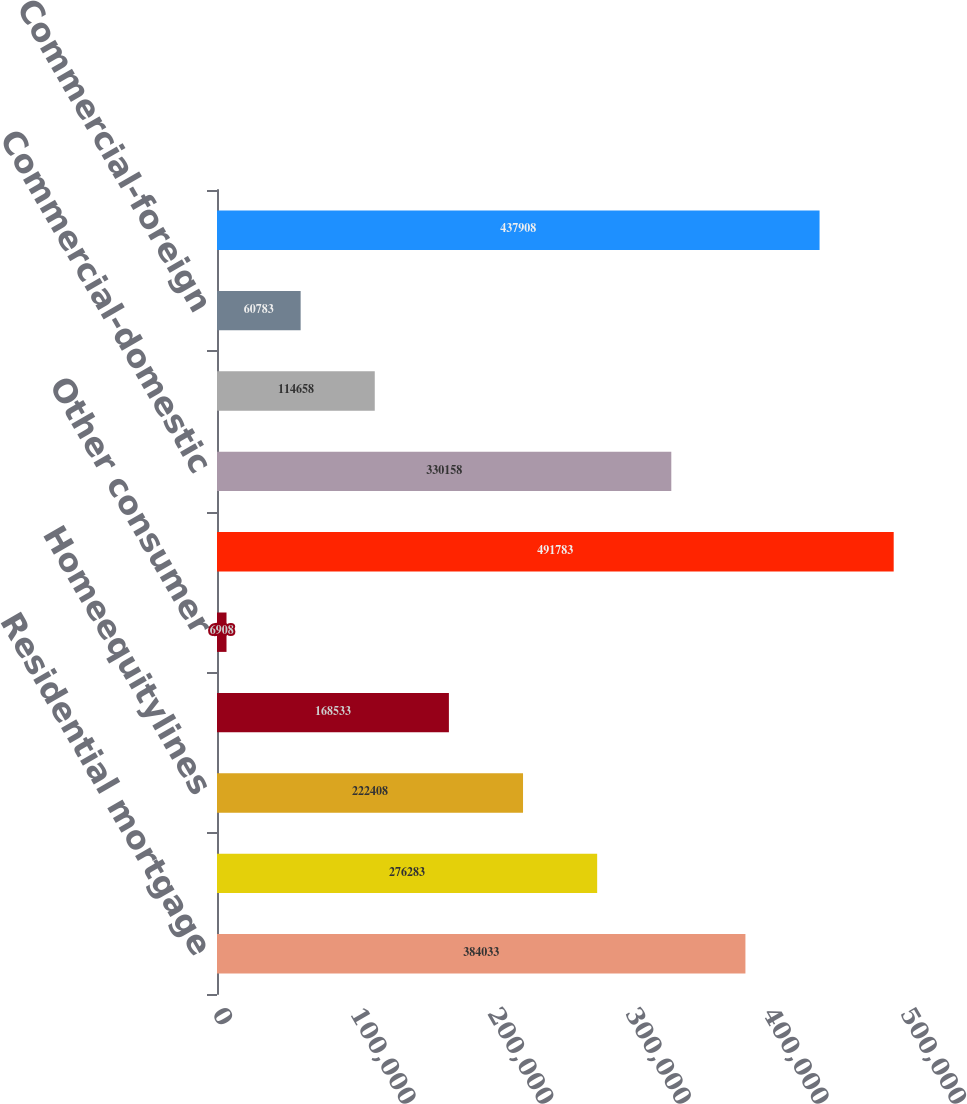Convert chart to OTSL. <chart><loc_0><loc_0><loc_500><loc_500><bar_chart><fcel>Residential mortgage<fcel>Creditcard<fcel>Homeequitylines<fcel>Direct/Indirect consumer<fcel>Other consumer<fcel>Total consumer<fcel>Commercial-domestic<fcel>Commercial lease financing<fcel>Commercial-foreign<fcel>Total commercial<nl><fcel>384033<fcel>276283<fcel>222408<fcel>168533<fcel>6908<fcel>491783<fcel>330158<fcel>114658<fcel>60783<fcel>437908<nl></chart> 